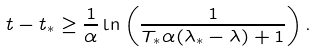Convert formula to latex. <formula><loc_0><loc_0><loc_500><loc_500>t - t _ { * } \geq \frac { 1 } { \alpha } \ln \left ( \frac { 1 } { T _ { * } \alpha ( \lambda _ { * } - \lambda ) + 1 } \right ) .</formula> 